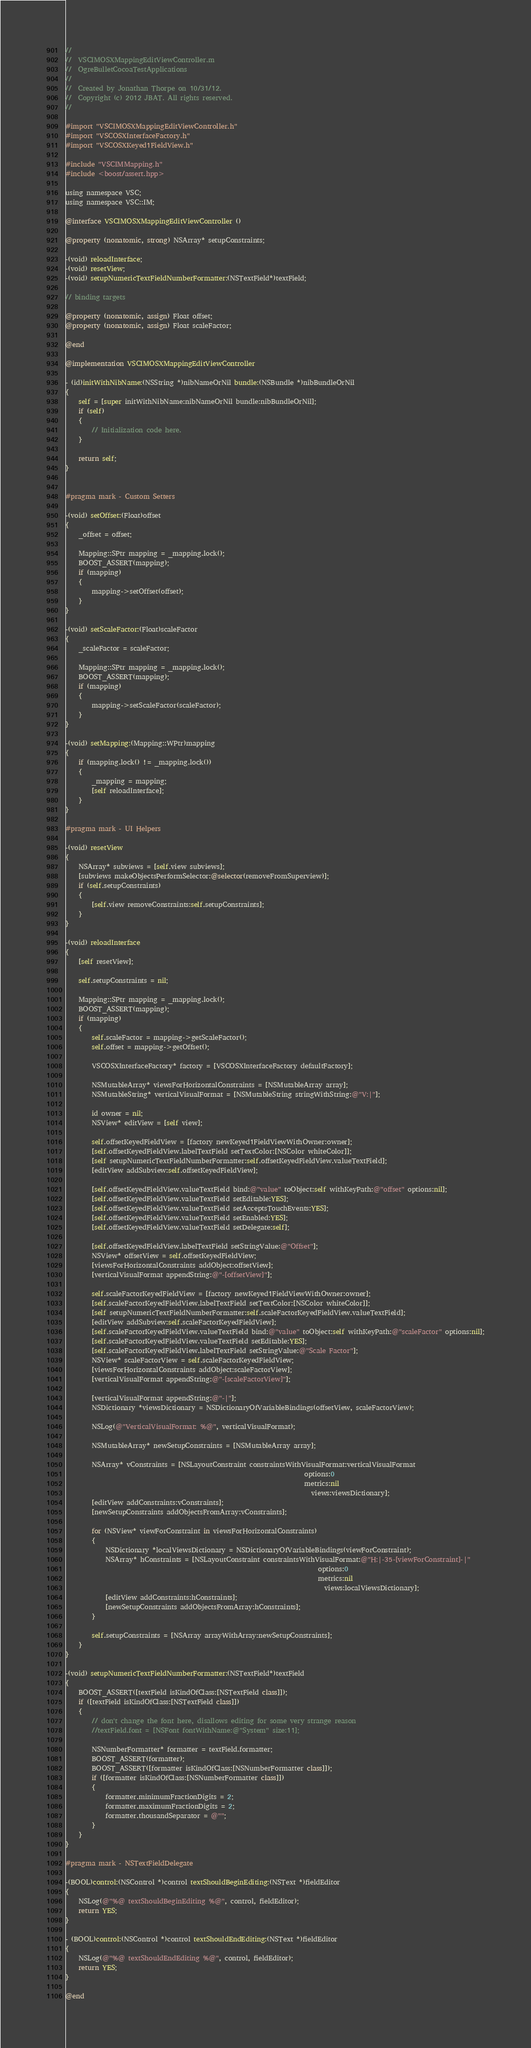<code> <loc_0><loc_0><loc_500><loc_500><_ObjectiveC_>//
//  VSCIMOSXMappingEditViewController.m
//  OgreBulletCocoaTestApplications
//
//  Created by Jonathan Thorpe on 10/31/12.
//  Copyright (c) 2012 JBAT. All rights reserved.
//

#import "VSCIMOSXMappingEditViewController.h"
#import "VSCOSXInterfaceFactory.h"
#import "VSCOSXKeyed1FieldView.h"

#include "VSCIMMapping.h"
#include <boost/assert.hpp>

using namespace VSC;
using namespace VSC::IM;

@interface VSCIMOSXMappingEditViewController ()

@property (nonatomic, strong) NSArray* setupConstraints;

-(void) reloadInterface;
-(void) resetView;
-(void) setupNumericTextFieldNumberFormatter:(NSTextField*)textField;

// binding targets

@property (nonatomic, assign) Float offset;
@property (nonatomic, assign) Float scaleFactor;

@end

@implementation VSCIMOSXMappingEditViewController

- (id)initWithNibName:(NSString *)nibNameOrNil bundle:(NSBundle *)nibBundleOrNil
{
    self = [super initWithNibName:nibNameOrNil bundle:nibBundleOrNil];
    if (self)
    {
        // Initialization code here.
    }
    
    return self;
}


#pragma mark - Custom Setters

-(void) setOffset:(Float)offset
{
    _offset = offset;
    
    Mapping::SPtr mapping = _mapping.lock();
    BOOST_ASSERT(mapping);
    if (mapping)
    {
        mapping->setOffset(offset);
    }
}

-(void) setScaleFactor:(Float)scaleFactor
{
    _scaleFactor = scaleFactor;
    
    Mapping::SPtr mapping = _mapping.lock();
    BOOST_ASSERT(mapping);
    if (mapping)
    {
        mapping->setScaleFactor(scaleFactor);
    }
}

-(void) setMapping:(Mapping::WPtr)mapping
{
    if (mapping.lock() != _mapping.lock())
    {
        _mapping = mapping;
        [self reloadInterface];
    }
}

#pragma mark - UI Helpers

-(void) resetView
{
    NSArray* subviews = [self.view subviews];
    [subviews makeObjectsPerformSelector:@selector(removeFromSuperview)];
    if (self.setupConstraints)
    {
        [self.view removeConstraints:self.setupConstraints];
    }
}

-(void) reloadInterface
{
    [self resetView];
    
    self.setupConstraints = nil;
    
    Mapping::SPtr mapping = _mapping.lock();
    BOOST_ASSERT(mapping);
    if (mapping)
    {
        self.scaleFactor = mapping->getScaleFactor();
        self.offset = mapping->getOffset();
        
        VSCOSXInterfaceFactory* factory = [VSCOSXInterfaceFactory defaultFactory];
        
        NSMutableArray* viewsForHorizontalConstraints = [NSMutableArray array];
        NSMutableString* verticalVisualFormat = [NSMutableString stringWithString:@"V:|"];
        
        id owner = nil;
        NSView* editView = [self view];
        
        self.offsetKeyedFieldView = [factory newKeyed1FieldViewWithOwner:owner];
        [self.offsetKeyedFieldView.labelTextField setTextColor:[NSColor whiteColor]];
        [self setupNumericTextFieldNumberFormatter:self.offsetKeyedFieldView.valueTextField];
        [editView addSubview:self.offsetKeyedFieldView];
        
        [self.offsetKeyedFieldView.valueTextField bind:@"value" toObject:self withKeyPath:@"offset" options:nil];
        [self.offsetKeyedFieldView.valueTextField setEditable:YES];
        [self.offsetKeyedFieldView.valueTextField setAcceptsTouchEvents:YES];
        [self.offsetKeyedFieldView.valueTextField setEnabled:YES];
        [self.offsetKeyedFieldView.valueTextField setDelegate:self];
        
        [self.offsetKeyedFieldView.labelTextField setStringValue:@"Offset"];
        NSView* offsetView = self.offsetKeyedFieldView;
        [viewsForHorizontalConstraints addObject:offsetView];
        [verticalVisualFormat appendString:@"-[offsetView]"];
        
        self.scaleFactorKeyedFieldView = [factory newKeyed1FieldViewWithOwner:owner];
        [self.scaleFactorKeyedFieldView.labelTextField setTextColor:[NSColor whiteColor]];
        [self setupNumericTextFieldNumberFormatter:self.scaleFactorKeyedFieldView.valueTextField];
        [editView addSubview:self.scaleFactorKeyedFieldView];
        [self.scaleFactorKeyedFieldView.valueTextField bind:@"value" toObject:self withKeyPath:@"scaleFactor" options:nil];
        [self.scaleFactorKeyedFieldView.valueTextField setEditable:YES];
        [self.scaleFactorKeyedFieldView.labelTextField setStringValue:@"Scale Factor"];
        NSView* scaleFactorView = self.scaleFactorKeyedFieldView;
        [viewsForHorizontalConstraints addObject:scaleFactorView];
        [verticalVisualFormat appendString:@"-[scaleFactorView]"];
        
        [verticalVisualFormat appendString:@"-|"];
        NSDictionary *viewsDictionary = NSDictionaryOfVariableBindings(offsetView, scaleFactorView);
        
        NSLog(@"VerticalVisualFormat: %@", verticalVisualFormat);
        
        NSMutableArray* newSetupConstraints = [NSMutableArray array];
        
        NSArray* vConstraints = [NSLayoutConstraint constraintsWithVisualFormat:verticalVisualFormat
                                                                        options:0
                                                                        metrics:nil
                                                                          views:viewsDictionary];
        [editView addConstraints:vConstraints];
        [newSetupConstraints addObjectsFromArray:vConstraints];
        
        for (NSView* viewForConstraint in viewsForHorizontalConstraints)
        {
            NSDictionary *localViewsDictionary = NSDictionaryOfVariableBindings(viewForConstraint);
            NSArray* hConstraints = [NSLayoutConstraint constraintsWithVisualFormat:@"H:|-35-[viewForConstraint]-|"
                                                                            options:0
                                                                            metrics:nil
                                                                              views:localViewsDictionary];
            [editView addConstraints:hConstraints];
            [newSetupConstraints addObjectsFromArray:hConstraints];
        }
        
        self.setupConstraints = [NSArray arrayWithArray:newSetupConstraints];
    }
}

-(void) setupNumericTextFieldNumberFormatter:(NSTextField*)textField
{
    BOOST_ASSERT([textField isKindOfClass:[NSTextField class]]);
    if ([textField isKindOfClass:[NSTextField class]])
    {
        // don't change the font here, disallows editing for some very strange reason 
        //textField.font = [NSFont fontWithName:@"System" size:11];
        
        NSNumberFormatter* formatter = textField.formatter;
        BOOST_ASSERT(formatter);
        BOOST_ASSERT([formatter isKindOfClass:[NSNumberFormatter class]]);
        if ([formatter isKindOfClass:[NSNumberFormatter class]])
        {
            formatter.minimumFractionDigits = 2;
            formatter.maximumFractionDigits = 2;
            formatter.thousandSeparator = @"";
        }
    }
}

#pragma mark - NSTextFieldDelegate

-(BOOL)control:(NSControl *)control textShouldBeginEditing:(NSText *)fieldEditor
{
    NSLog(@"%@ textShouldBeginEditing %@", control, fieldEditor);
    return YES;
}

- (BOOL)control:(NSControl *)control textShouldEndEditing:(NSText *)fieldEditor
{
    NSLog(@"%@ textShouldEndEditing %@", control, fieldEditor);
    return YES;
}

@end
</code> 